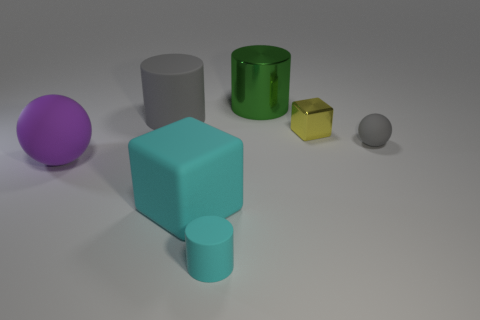The rubber object that is the same color as the big cube is what shape?
Provide a succinct answer. Cylinder. What is the shape of the big rubber object that is behind the big cyan block and in front of the small block?
Your answer should be compact. Sphere. Are there fewer tiny cyan rubber cylinders that are right of the tiny cyan thing than purple rubber spheres?
Your answer should be very brief. Yes. How many small things are either green cylinders or brown cylinders?
Give a very brief answer. 0. What is the size of the yellow shiny thing?
Provide a short and direct response. Small. There is a tiny gray sphere; what number of green metallic cylinders are in front of it?
Make the answer very short. 0. What size is the cyan rubber object that is the same shape as the tiny yellow object?
Offer a terse response. Large. What size is the matte thing that is both right of the big matte cube and behind the cyan cylinder?
Offer a terse response. Small. There is a tiny cylinder; does it have the same color as the big matte thing on the right side of the large gray cylinder?
Keep it short and to the point. Yes. What number of cyan things are either metal cylinders or large rubber objects?
Your answer should be compact. 1. 